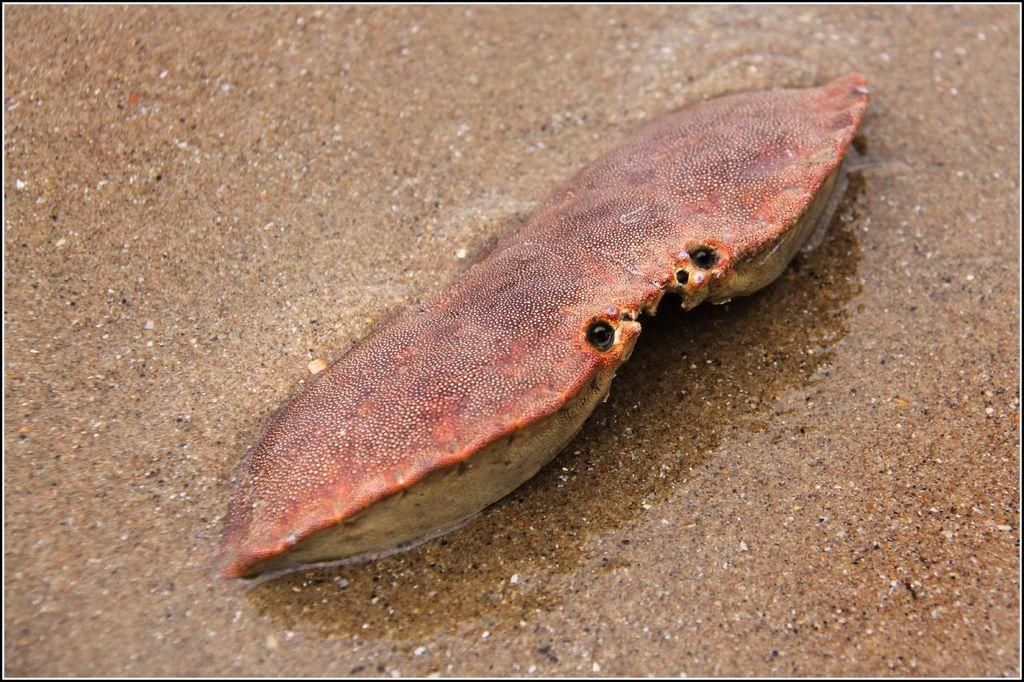Please provide a concise description of this image. This image consists of a marine animal. It is in brown color. At the bottom, we can see the sand. 